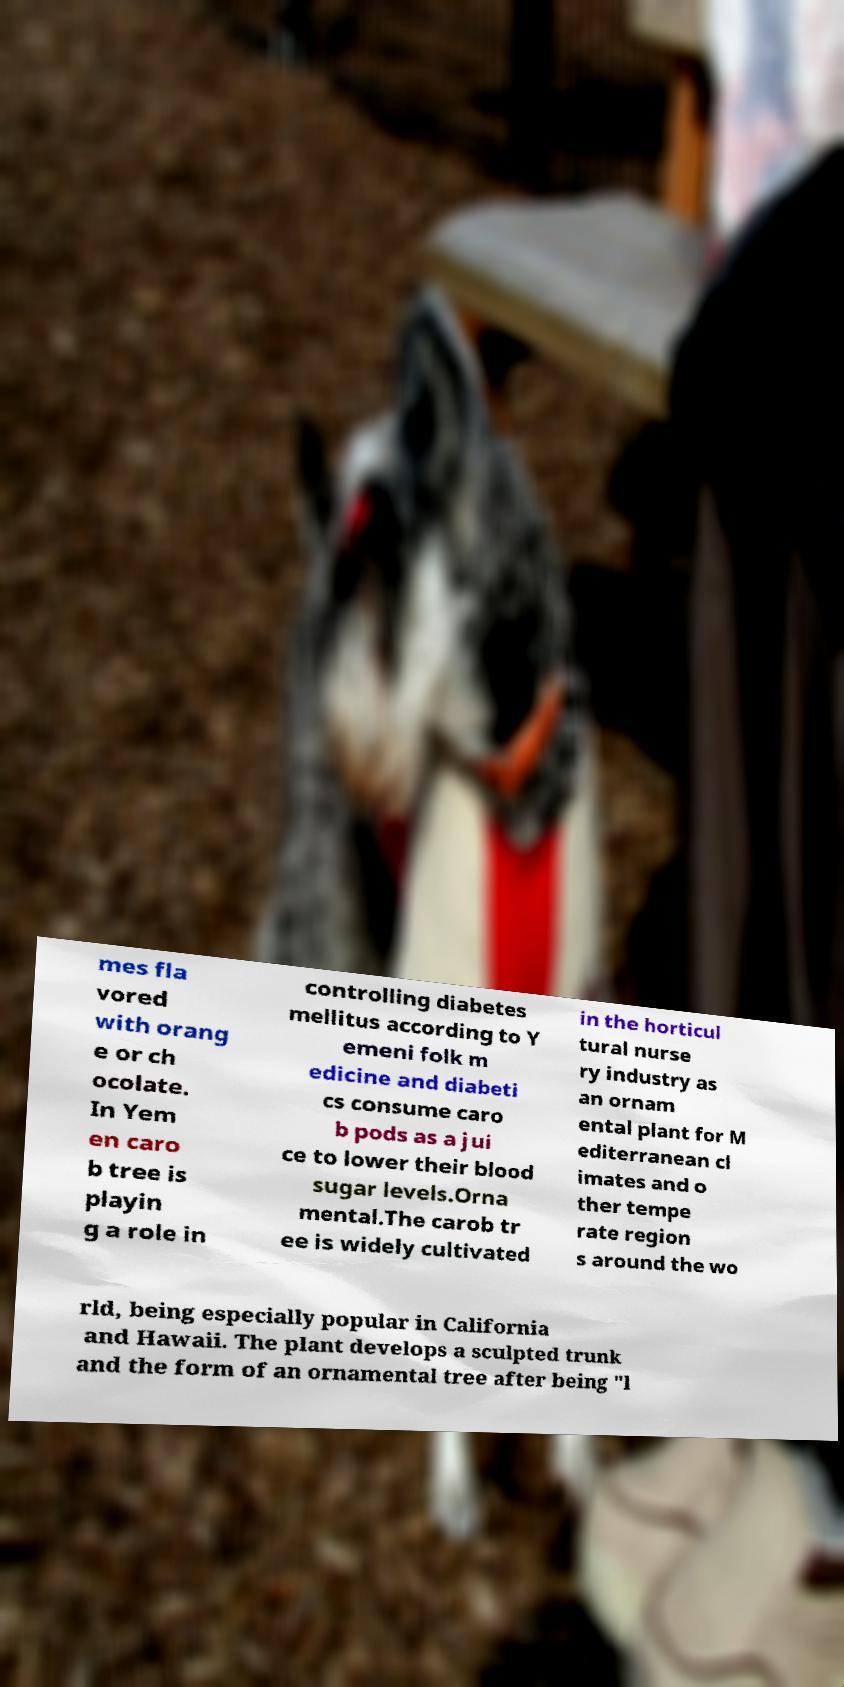Could you assist in decoding the text presented in this image and type it out clearly? mes fla vored with orang e or ch ocolate. In Yem en caro b tree is playin g a role in controlling diabetes mellitus according to Y emeni folk m edicine and diabeti cs consume caro b pods as a jui ce to lower their blood sugar levels.Orna mental.The carob tr ee is widely cultivated in the horticul tural nurse ry industry as an ornam ental plant for M editerranean cl imates and o ther tempe rate region s around the wo rld, being especially popular in California and Hawaii. The plant develops a sculpted trunk and the form of an ornamental tree after being "l 